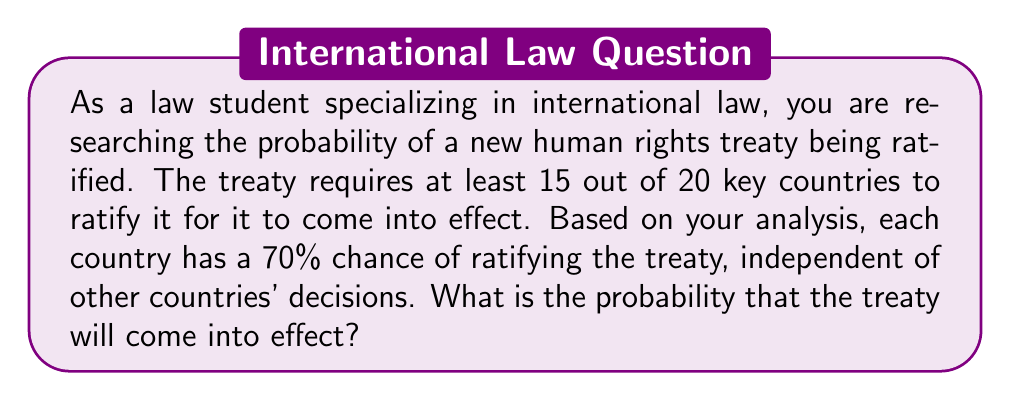Can you answer this question? To solve this problem, we need to use the binomial probability distribution. The scenario fits the binomial distribution because:

1. There are a fixed number of trials (20 countries).
2. Each trial has two possible outcomes (ratify or not ratify).
3. The probability of success (ratification) is the same for each trial (70%).
4. The trials are independent.

We want to find the probability of 15 or more countries ratifying the treaty. This can be calculated as:

$P(X \geq 15) = 1 - P(X \leq 14)$

Where $X$ is the number of countries that ratify the treaty.

The probability mass function for the binomial distribution is:

$P(X = k) = \binom{n}{k} p^k (1-p)^{n-k}$

Where:
$n$ = number of trials (20)
$k$ = number of successes
$p$ = probability of success (0.70)

We need to calculate:

$P(X \geq 15) = 1 - [P(X = 0) + P(X = 1) + ... + P(X = 14)]$

Using a calculator or computer program (as manual calculation would be time-consuming), we find:

$P(X \geq 15) = 1 - 0.0523$

$P(X \geq 15) = 0.9477$
Answer: The probability that the treaty will come into effect is approximately 0.9477 or 94.77%. 